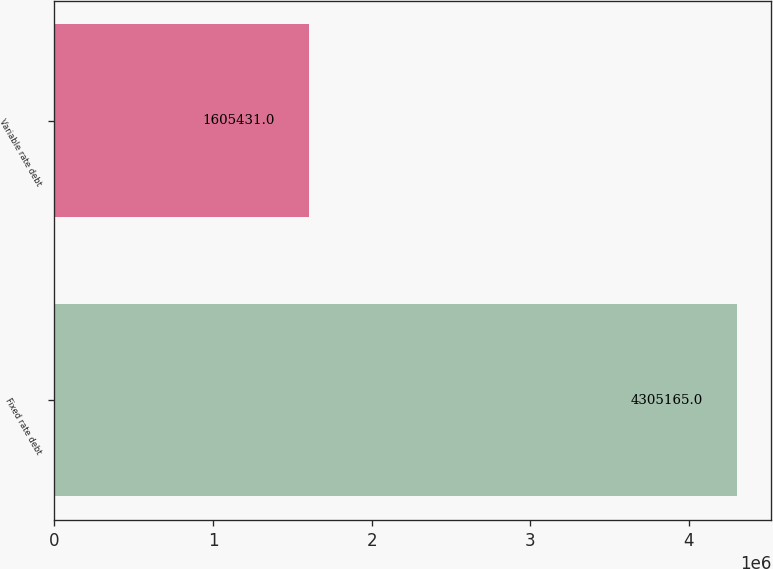Convert chart. <chart><loc_0><loc_0><loc_500><loc_500><bar_chart><fcel>Fixed rate debt<fcel>Variable rate debt<nl><fcel>4.30516e+06<fcel>1.60543e+06<nl></chart> 